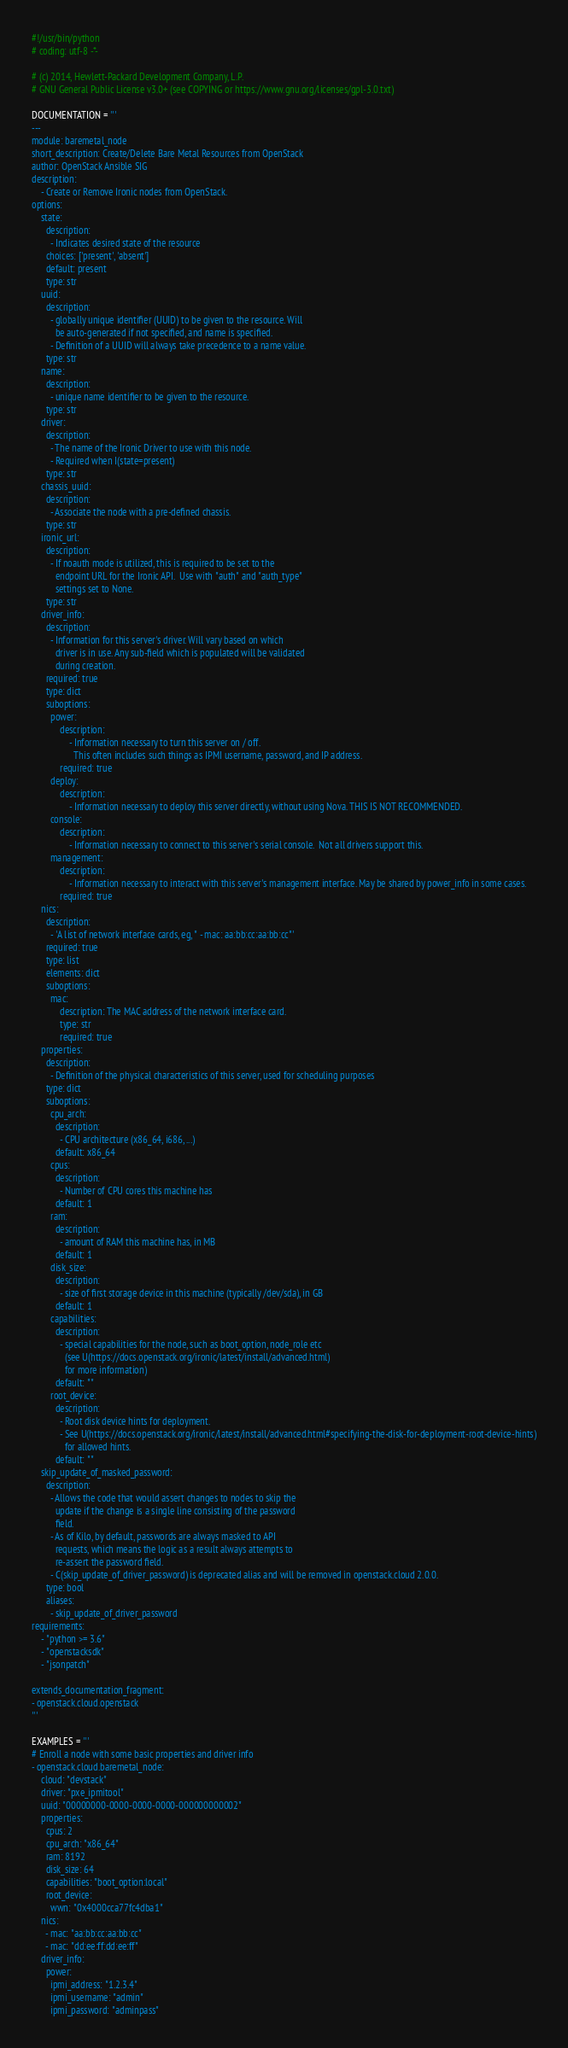Convert code to text. <code><loc_0><loc_0><loc_500><loc_500><_Python_>#!/usr/bin/python
# coding: utf-8 -*-

# (c) 2014, Hewlett-Packard Development Company, L.P.
# GNU General Public License v3.0+ (see COPYING or https://www.gnu.org/licenses/gpl-3.0.txt)

DOCUMENTATION = '''
---
module: baremetal_node
short_description: Create/Delete Bare Metal Resources from OpenStack
author: OpenStack Ansible SIG
description:
    - Create or Remove Ironic nodes from OpenStack.
options:
    state:
      description:
        - Indicates desired state of the resource
      choices: ['present', 'absent']
      default: present
      type: str
    uuid:
      description:
        - globally unique identifier (UUID) to be given to the resource. Will
          be auto-generated if not specified, and name is specified.
        - Definition of a UUID will always take precedence to a name value.
      type: str
    name:
      description:
        - unique name identifier to be given to the resource.
      type: str
    driver:
      description:
        - The name of the Ironic Driver to use with this node.
        - Required when I(state=present)
      type: str
    chassis_uuid:
      description:
        - Associate the node with a pre-defined chassis.
      type: str
    ironic_url:
      description:
        - If noauth mode is utilized, this is required to be set to the
          endpoint URL for the Ironic API.  Use with "auth" and "auth_type"
          settings set to None.
      type: str
    driver_info:
      description:
        - Information for this server's driver. Will vary based on which
          driver is in use. Any sub-field which is populated will be validated
          during creation.
      required: true
      type: dict
      suboptions:
        power:
            description:
                - Information necessary to turn this server on / off.
                  This often includes such things as IPMI username, password, and IP address.
            required: true
        deploy:
            description:
                - Information necessary to deploy this server directly, without using Nova. THIS IS NOT RECOMMENDED.
        console:
            description:
                - Information necessary to connect to this server's serial console.  Not all drivers support this.
        management:
            description:
                - Information necessary to interact with this server's management interface. May be shared by power_info in some cases.
            required: true
    nics:
      description:
        - 'A list of network interface cards, eg, " - mac: aa:bb:cc:aa:bb:cc"'
      required: true
      type: list
      elements: dict
      suboptions:
        mac:
            description: The MAC address of the network interface card.
            type: str
            required: true
    properties:
      description:
        - Definition of the physical characteristics of this server, used for scheduling purposes
      type: dict
      suboptions:
        cpu_arch:
          description:
            - CPU architecture (x86_64, i686, ...)
          default: x86_64
        cpus:
          description:
            - Number of CPU cores this machine has
          default: 1
        ram:
          description:
            - amount of RAM this machine has, in MB
          default: 1
        disk_size:
          description:
            - size of first storage device in this machine (typically /dev/sda), in GB
          default: 1
        capabilities:
          description:
            - special capabilities for the node, such as boot_option, node_role etc
              (see U(https://docs.openstack.org/ironic/latest/install/advanced.html)
              for more information)
          default: ""
        root_device:
          description:
            - Root disk device hints for deployment.
            - See U(https://docs.openstack.org/ironic/latest/install/advanced.html#specifying-the-disk-for-deployment-root-device-hints)
              for allowed hints.
          default: ""
    skip_update_of_masked_password:
      description:
        - Allows the code that would assert changes to nodes to skip the
          update if the change is a single line consisting of the password
          field.
        - As of Kilo, by default, passwords are always masked to API
          requests, which means the logic as a result always attempts to
          re-assert the password field.
        - C(skip_update_of_driver_password) is deprecated alias and will be removed in openstack.cloud 2.0.0.
      type: bool
      aliases:
        - skip_update_of_driver_password
requirements:
    - "python >= 3.6"
    - "openstacksdk"
    - "jsonpatch"

extends_documentation_fragment:
- openstack.cloud.openstack
'''

EXAMPLES = '''
# Enroll a node with some basic properties and driver info
- openstack.cloud.baremetal_node:
    cloud: "devstack"
    driver: "pxe_ipmitool"
    uuid: "00000000-0000-0000-0000-000000000002"
    properties:
      cpus: 2
      cpu_arch: "x86_64"
      ram: 8192
      disk_size: 64
      capabilities: "boot_option:local"
      root_device:
        wwn: "0x4000cca77fc4dba1"
    nics:
      - mac: "aa:bb:cc:aa:bb:cc"
      - mac: "dd:ee:ff:dd:ee:ff"
    driver_info:
      power:
        ipmi_address: "1.2.3.4"
        ipmi_username: "admin"
        ipmi_password: "adminpass"</code> 